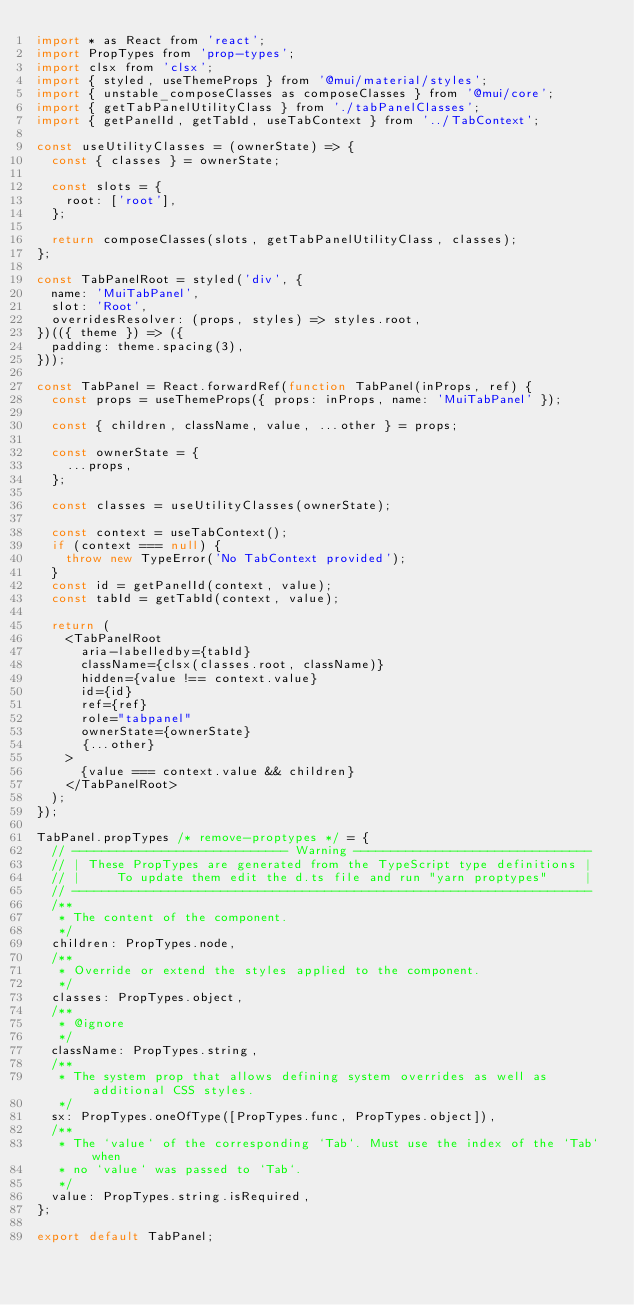<code> <loc_0><loc_0><loc_500><loc_500><_JavaScript_>import * as React from 'react';
import PropTypes from 'prop-types';
import clsx from 'clsx';
import { styled, useThemeProps } from '@mui/material/styles';
import { unstable_composeClasses as composeClasses } from '@mui/core';
import { getTabPanelUtilityClass } from './tabPanelClasses';
import { getPanelId, getTabId, useTabContext } from '../TabContext';

const useUtilityClasses = (ownerState) => {
  const { classes } = ownerState;

  const slots = {
    root: ['root'],
  };

  return composeClasses(slots, getTabPanelUtilityClass, classes);
};

const TabPanelRoot = styled('div', {
  name: 'MuiTabPanel',
  slot: 'Root',
  overridesResolver: (props, styles) => styles.root,
})(({ theme }) => ({
  padding: theme.spacing(3),
}));

const TabPanel = React.forwardRef(function TabPanel(inProps, ref) {
  const props = useThemeProps({ props: inProps, name: 'MuiTabPanel' });

  const { children, className, value, ...other } = props;

  const ownerState = {
    ...props,
  };

  const classes = useUtilityClasses(ownerState);

  const context = useTabContext();
  if (context === null) {
    throw new TypeError('No TabContext provided');
  }
  const id = getPanelId(context, value);
  const tabId = getTabId(context, value);

  return (
    <TabPanelRoot
      aria-labelledby={tabId}
      className={clsx(classes.root, className)}
      hidden={value !== context.value}
      id={id}
      ref={ref}
      role="tabpanel"
      ownerState={ownerState}
      {...other}
    >
      {value === context.value && children}
    </TabPanelRoot>
  );
});

TabPanel.propTypes /* remove-proptypes */ = {
  // ----------------------------- Warning --------------------------------
  // | These PropTypes are generated from the TypeScript type definitions |
  // |     To update them edit the d.ts file and run "yarn proptypes"     |
  // ----------------------------------------------------------------------
  /**
   * The content of the component.
   */
  children: PropTypes.node,
  /**
   * Override or extend the styles applied to the component.
   */
  classes: PropTypes.object,
  /**
   * @ignore
   */
  className: PropTypes.string,
  /**
   * The system prop that allows defining system overrides as well as additional CSS styles.
   */
  sx: PropTypes.oneOfType([PropTypes.func, PropTypes.object]),
  /**
   * The `value` of the corresponding `Tab`. Must use the index of the `Tab` when
   * no `value` was passed to `Tab`.
   */
  value: PropTypes.string.isRequired,
};

export default TabPanel;
</code> 